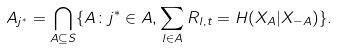<formula> <loc_0><loc_0><loc_500><loc_500>A _ { j ^ { * } } = \bigcap _ { A \subseteq S } \{ A \colon j ^ { * } \in A , \sum _ { l \in A } R _ { l , t } = H ( X _ { A } | X _ { - A } ) \} .</formula> 